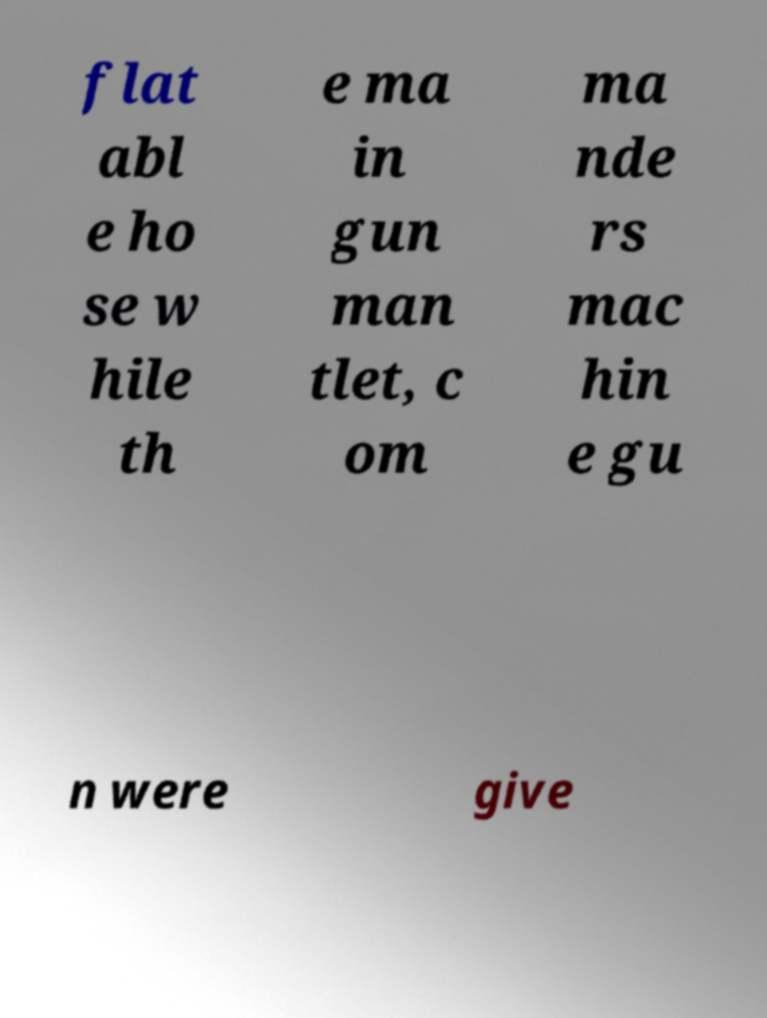For documentation purposes, I need the text within this image transcribed. Could you provide that? flat abl e ho se w hile th e ma in gun man tlet, c om ma nde rs mac hin e gu n were give 